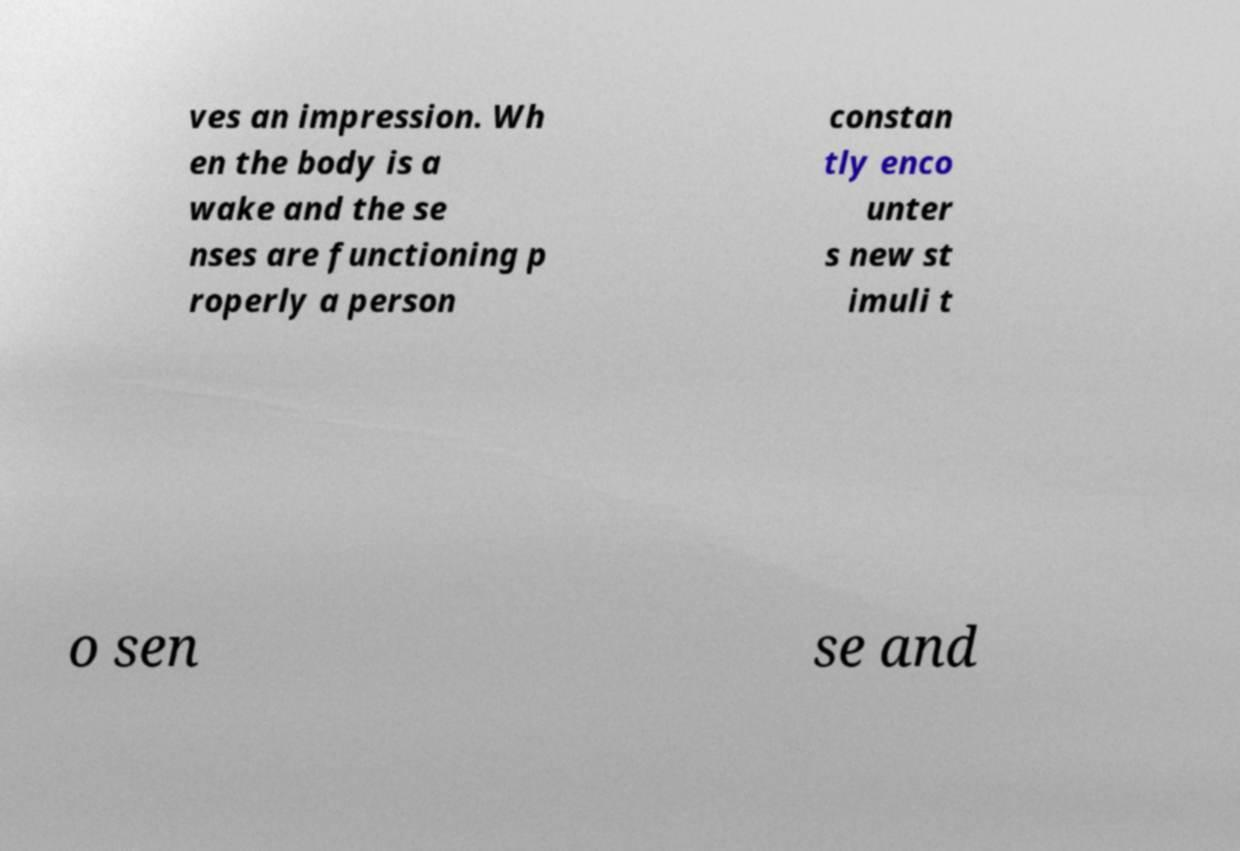Please identify and transcribe the text found in this image. ves an impression. Wh en the body is a wake and the se nses are functioning p roperly a person constan tly enco unter s new st imuli t o sen se and 